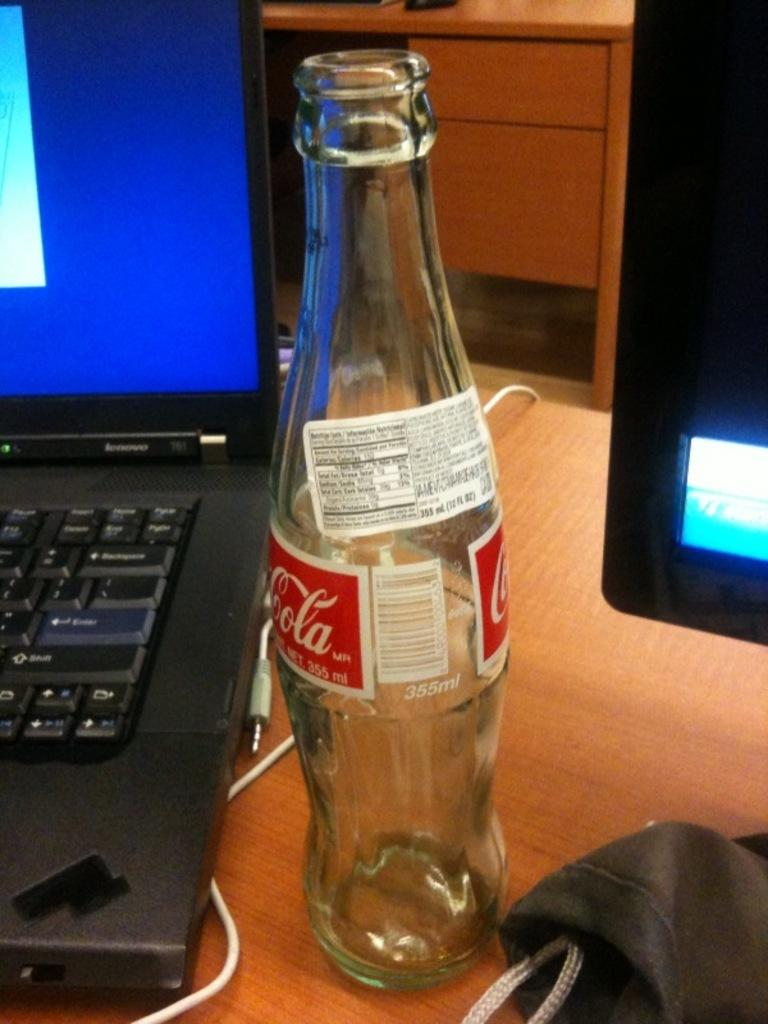<image>
Render a clear and concise summary of the photo. Bottle of Coca Cola sitting next to a laptop. 